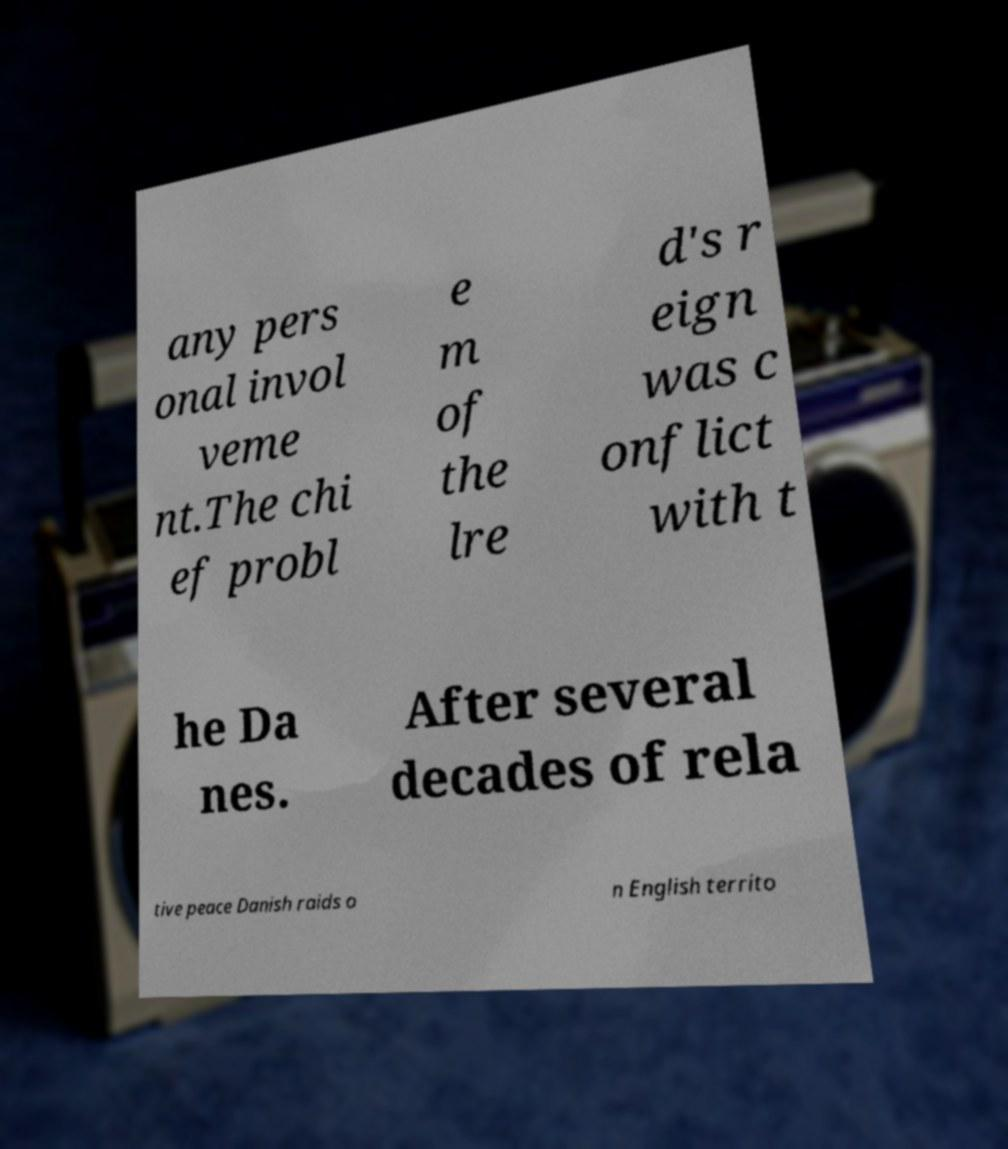For documentation purposes, I need the text within this image transcribed. Could you provide that? any pers onal invol veme nt.The chi ef probl e m of the lre d's r eign was c onflict with t he Da nes. After several decades of rela tive peace Danish raids o n English territo 